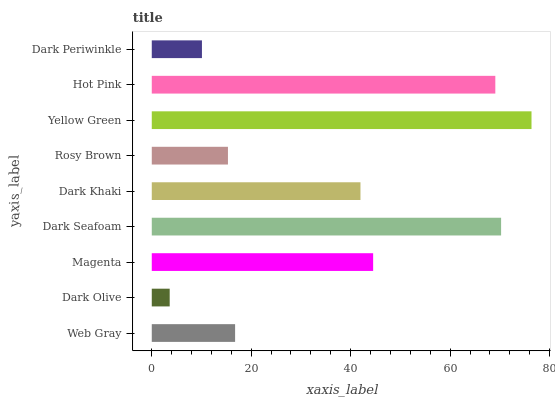Is Dark Olive the minimum?
Answer yes or no. Yes. Is Yellow Green the maximum?
Answer yes or no. Yes. Is Magenta the minimum?
Answer yes or no. No. Is Magenta the maximum?
Answer yes or no. No. Is Magenta greater than Dark Olive?
Answer yes or no. Yes. Is Dark Olive less than Magenta?
Answer yes or no. Yes. Is Dark Olive greater than Magenta?
Answer yes or no. No. Is Magenta less than Dark Olive?
Answer yes or no. No. Is Dark Khaki the high median?
Answer yes or no. Yes. Is Dark Khaki the low median?
Answer yes or no. Yes. Is Magenta the high median?
Answer yes or no. No. Is Dark Olive the low median?
Answer yes or no. No. 